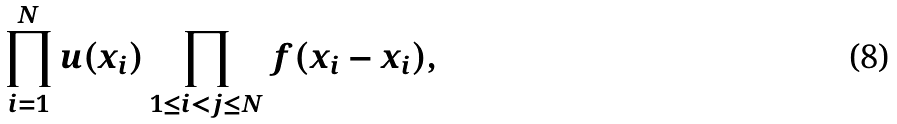<formula> <loc_0><loc_0><loc_500><loc_500>\prod _ { i = 1 } ^ { N } u ( x _ { i } ) \prod _ { 1 \leq i < j \leq N } f ( x _ { i } - x _ { i } ) ,</formula> 